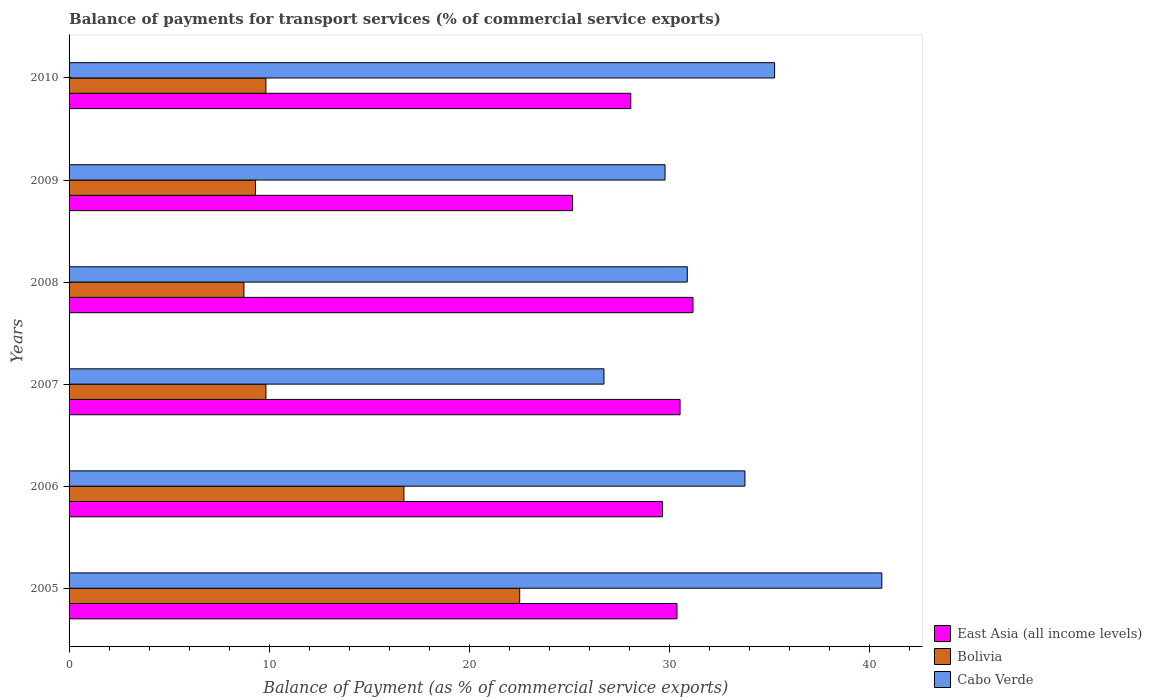How many different coloured bars are there?
Make the answer very short. 3. How many groups of bars are there?
Offer a terse response. 6. Are the number of bars per tick equal to the number of legend labels?
Offer a very short reply. Yes. Are the number of bars on each tick of the Y-axis equal?
Provide a succinct answer. Yes. How many bars are there on the 6th tick from the top?
Ensure brevity in your answer.  3. What is the label of the 6th group of bars from the top?
Your answer should be compact. 2005. What is the balance of payments for transport services in Cabo Verde in 2008?
Provide a succinct answer. 30.91. Across all years, what is the maximum balance of payments for transport services in Cabo Verde?
Your response must be concise. 40.64. Across all years, what is the minimum balance of payments for transport services in East Asia (all income levels)?
Your answer should be very brief. 25.18. In which year was the balance of payments for transport services in Bolivia maximum?
Provide a succinct answer. 2005. What is the total balance of payments for transport services in East Asia (all income levels) in the graph?
Your answer should be compact. 175.08. What is the difference between the balance of payments for transport services in Cabo Verde in 2007 and that in 2008?
Give a very brief answer. -4.17. What is the difference between the balance of payments for transport services in Bolivia in 2006 and the balance of payments for transport services in Cabo Verde in 2009?
Provide a short and direct response. -13.06. What is the average balance of payments for transport services in East Asia (all income levels) per year?
Give a very brief answer. 29.18. In the year 2005, what is the difference between the balance of payments for transport services in Bolivia and balance of payments for transport services in Cabo Verde?
Offer a terse response. -18.11. In how many years, is the balance of payments for transport services in East Asia (all income levels) greater than 14 %?
Offer a very short reply. 6. What is the ratio of the balance of payments for transport services in East Asia (all income levels) in 2007 to that in 2008?
Make the answer very short. 0.98. Is the balance of payments for transport services in Cabo Verde in 2005 less than that in 2009?
Offer a terse response. No. Is the difference between the balance of payments for transport services in Bolivia in 2005 and 2010 greater than the difference between the balance of payments for transport services in Cabo Verde in 2005 and 2010?
Provide a succinct answer. Yes. What is the difference between the highest and the second highest balance of payments for transport services in Cabo Verde?
Offer a very short reply. 5.36. What is the difference between the highest and the lowest balance of payments for transport services in Cabo Verde?
Offer a very short reply. 13.89. In how many years, is the balance of payments for transport services in Cabo Verde greater than the average balance of payments for transport services in Cabo Verde taken over all years?
Your answer should be very brief. 3. What does the 3rd bar from the top in 2010 represents?
Make the answer very short. East Asia (all income levels). What does the 3rd bar from the bottom in 2005 represents?
Keep it short and to the point. Cabo Verde. Is it the case that in every year, the sum of the balance of payments for transport services in Bolivia and balance of payments for transport services in East Asia (all income levels) is greater than the balance of payments for transport services in Cabo Verde?
Give a very brief answer. Yes. How many bars are there?
Provide a succinct answer. 18. Are all the bars in the graph horizontal?
Provide a short and direct response. Yes. What is the difference between two consecutive major ticks on the X-axis?
Your answer should be compact. 10. Are the values on the major ticks of X-axis written in scientific E-notation?
Give a very brief answer. No. Where does the legend appear in the graph?
Your answer should be very brief. Bottom right. What is the title of the graph?
Keep it short and to the point. Balance of payments for transport services (% of commercial service exports). Does "Dominican Republic" appear as one of the legend labels in the graph?
Your response must be concise. No. What is the label or title of the X-axis?
Your response must be concise. Balance of Payment (as % of commercial service exports). What is the Balance of Payment (as % of commercial service exports) of East Asia (all income levels) in 2005?
Your answer should be compact. 30.4. What is the Balance of Payment (as % of commercial service exports) of Bolivia in 2005?
Provide a short and direct response. 22.53. What is the Balance of Payment (as % of commercial service exports) of Cabo Verde in 2005?
Offer a terse response. 40.64. What is the Balance of Payment (as % of commercial service exports) in East Asia (all income levels) in 2006?
Your answer should be very brief. 29.67. What is the Balance of Payment (as % of commercial service exports) in Bolivia in 2006?
Provide a short and direct response. 16.74. What is the Balance of Payment (as % of commercial service exports) in Cabo Verde in 2006?
Your answer should be very brief. 33.79. What is the Balance of Payment (as % of commercial service exports) of East Asia (all income levels) in 2007?
Provide a short and direct response. 30.55. What is the Balance of Payment (as % of commercial service exports) of Bolivia in 2007?
Your answer should be compact. 9.84. What is the Balance of Payment (as % of commercial service exports) of Cabo Verde in 2007?
Make the answer very short. 26.75. What is the Balance of Payment (as % of commercial service exports) of East Asia (all income levels) in 2008?
Your answer should be very brief. 31.2. What is the Balance of Payment (as % of commercial service exports) in Bolivia in 2008?
Your answer should be compact. 8.74. What is the Balance of Payment (as % of commercial service exports) in Cabo Verde in 2008?
Offer a terse response. 30.91. What is the Balance of Payment (as % of commercial service exports) in East Asia (all income levels) in 2009?
Offer a very short reply. 25.18. What is the Balance of Payment (as % of commercial service exports) of Bolivia in 2009?
Provide a succinct answer. 9.32. What is the Balance of Payment (as % of commercial service exports) in Cabo Verde in 2009?
Your answer should be compact. 29.8. What is the Balance of Payment (as % of commercial service exports) in East Asia (all income levels) in 2010?
Give a very brief answer. 28.09. What is the Balance of Payment (as % of commercial service exports) of Bolivia in 2010?
Offer a terse response. 9.84. What is the Balance of Payment (as % of commercial service exports) of Cabo Verde in 2010?
Provide a short and direct response. 35.28. Across all years, what is the maximum Balance of Payment (as % of commercial service exports) in East Asia (all income levels)?
Ensure brevity in your answer.  31.2. Across all years, what is the maximum Balance of Payment (as % of commercial service exports) of Bolivia?
Ensure brevity in your answer.  22.53. Across all years, what is the maximum Balance of Payment (as % of commercial service exports) of Cabo Verde?
Provide a succinct answer. 40.64. Across all years, what is the minimum Balance of Payment (as % of commercial service exports) of East Asia (all income levels)?
Give a very brief answer. 25.18. Across all years, what is the minimum Balance of Payment (as % of commercial service exports) of Bolivia?
Give a very brief answer. 8.74. Across all years, what is the minimum Balance of Payment (as % of commercial service exports) in Cabo Verde?
Your answer should be compact. 26.75. What is the total Balance of Payment (as % of commercial service exports) in East Asia (all income levels) in the graph?
Offer a very short reply. 175.08. What is the total Balance of Payment (as % of commercial service exports) of Bolivia in the graph?
Your response must be concise. 77.03. What is the total Balance of Payment (as % of commercial service exports) in Cabo Verde in the graph?
Give a very brief answer. 197.17. What is the difference between the Balance of Payment (as % of commercial service exports) in East Asia (all income levels) in 2005 and that in 2006?
Give a very brief answer. 0.72. What is the difference between the Balance of Payment (as % of commercial service exports) of Bolivia in 2005 and that in 2006?
Ensure brevity in your answer.  5.79. What is the difference between the Balance of Payment (as % of commercial service exports) in Cabo Verde in 2005 and that in 2006?
Your answer should be compact. 6.85. What is the difference between the Balance of Payment (as % of commercial service exports) in East Asia (all income levels) in 2005 and that in 2007?
Your answer should be compact. -0.15. What is the difference between the Balance of Payment (as % of commercial service exports) in Bolivia in 2005 and that in 2007?
Keep it short and to the point. 12.69. What is the difference between the Balance of Payment (as % of commercial service exports) of Cabo Verde in 2005 and that in 2007?
Your answer should be compact. 13.89. What is the difference between the Balance of Payment (as % of commercial service exports) in East Asia (all income levels) in 2005 and that in 2008?
Offer a very short reply. -0.8. What is the difference between the Balance of Payment (as % of commercial service exports) of Bolivia in 2005 and that in 2008?
Keep it short and to the point. 13.79. What is the difference between the Balance of Payment (as % of commercial service exports) in Cabo Verde in 2005 and that in 2008?
Your answer should be compact. 9.73. What is the difference between the Balance of Payment (as % of commercial service exports) in East Asia (all income levels) in 2005 and that in 2009?
Give a very brief answer. 5.22. What is the difference between the Balance of Payment (as % of commercial service exports) of Bolivia in 2005 and that in 2009?
Offer a very short reply. 13.21. What is the difference between the Balance of Payment (as % of commercial service exports) in Cabo Verde in 2005 and that in 2009?
Keep it short and to the point. 10.84. What is the difference between the Balance of Payment (as % of commercial service exports) of East Asia (all income levels) in 2005 and that in 2010?
Your response must be concise. 2.31. What is the difference between the Balance of Payment (as % of commercial service exports) of Bolivia in 2005 and that in 2010?
Provide a succinct answer. 12.69. What is the difference between the Balance of Payment (as % of commercial service exports) of Cabo Verde in 2005 and that in 2010?
Give a very brief answer. 5.36. What is the difference between the Balance of Payment (as % of commercial service exports) in East Asia (all income levels) in 2006 and that in 2007?
Provide a short and direct response. -0.88. What is the difference between the Balance of Payment (as % of commercial service exports) of Bolivia in 2006 and that in 2007?
Provide a short and direct response. 6.9. What is the difference between the Balance of Payment (as % of commercial service exports) of Cabo Verde in 2006 and that in 2007?
Ensure brevity in your answer.  7.05. What is the difference between the Balance of Payment (as % of commercial service exports) in East Asia (all income levels) in 2006 and that in 2008?
Your answer should be very brief. -1.52. What is the difference between the Balance of Payment (as % of commercial service exports) in Bolivia in 2006 and that in 2008?
Provide a succinct answer. 8. What is the difference between the Balance of Payment (as % of commercial service exports) in Cabo Verde in 2006 and that in 2008?
Your response must be concise. 2.88. What is the difference between the Balance of Payment (as % of commercial service exports) of East Asia (all income levels) in 2006 and that in 2009?
Give a very brief answer. 4.5. What is the difference between the Balance of Payment (as % of commercial service exports) in Bolivia in 2006 and that in 2009?
Ensure brevity in your answer.  7.42. What is the difference between the Balance of Payment (as % of commercial service exports) of Cabo Verde in 2006 and that in 2009?
Make the answer very short. 3.99. What is the difference between the Balance of Payment (as % of commercial service exports) of East Asia (all income levels) in 2006 and that in 2010?
Keep it short and to the point. 1.59. What is the difference between the Balance of Payment (as % of commercial service exports) in Bolivia in 2006 and that in 2010?
Ensure brevity in your answer.  6.9. What is the difference between the Balance of Payment (as % of commercial service exports) in Cabo Verde in 2006 and that in 2010?
Provide a succinct answer. -1.48. What is the difference between the Balance of Payment (as % of commercial service exports) of East Asia (all income levels) in 2007 and that in 2008?
Offer a terse response. -0.65. What is the difference between the Balance of Payment (as % of commercial service exports) in Bolivia in 2007 and that in 2008?
Provide a succinct answer. 1.1. What is the difference between the Balance of Payment (as % of commercial service exports) of Cabo Verde in 2007 and that in 2008?
Your answer should be compact. -4.17. What is the difference between the Balance of Payment (as % of commercial service exports) of East Asia (all income levels) in 2007 and that in 2009?
Offer a very short reply. 5.37. What is the difference between the Balance of Payment (as % of commercial service exports) of Bolivia in 2007 and that in 2009?
Your response must be concise. 0.52. What is the difference between the Balance of Payment (as % of commercial service exports) of Cabo Verde in 2007 and that in 2009?
Provide a succinct answer. -3.05. What is the difference between the Balance of Payment (as % of commercial service exports) of East Asia (all income levels) in 2007 and that in 2010?
Give a very brief answer. 2.46. What is the difference between the Balance of Payment (as % of commercial service exports) in Bolivia in 2007 and that in 2010?
Ensure brevity in your answer.  0. What is the difference between the Balance of Payment (as % of commercial service exports) of Cabo Verde in 2007 and that in 2010?
Make the answer very short. -8.53. What is the difference between the Balance of Payment (as % of commercial service exports) of East Asia (all income levels) in 2008 and that in 2009?
Your answer should be compact. 6.02. What is the difference between the Balance of Payment (as % of commercial service exports) in Bolivia in 2008 and that in 2009?
Make the answer very short. -0.58. What is the difference between the Balance of Payment (as % of commercial service exports) in Cabo Verde in 2008 and that in 2009?
Your answer should be compact. 1.11. What is the difference between the Balance of Payment (as % of commercial service exports) in East Asia (all income levels) in 2008 and that in 2010?
Give a very brief answer. 3.11. What is the difference between the Balance of Payment (as % of commercial service exports) of Bolivia in 2008 and that in 2010?
Provide a short and direct response. -1.1. What is the difference between the Balance of Payment (as % of commercial service exports) in Cabo Verde in 2008 and that in 2010?
Offer a terse response. -4.37. What is the difference between the Balance of Payment (as % of commercial service exports) in East Asia (all income levels) in 2009 and that in 2010?
Your response must be concise. -2.91. What is the difference between the Balance of Payment (as % of commercial service exports) of Bolivia in 2009 and that in 2010?
Provide a succinct answer. -0.52. What is the difference between the Balance of Payment (as % of commercial service exports) of Cabo Verde in 2009 and that in 2010?
Your answer should be very brief. -5.48. What is the difference between the Balance of Payment (as % of commercial service exports) in East Asia (all income levels) in 2005 and the Balance of Payment (as % of commercial service exports) in Bolivia in 2006?
Your answer should be compact. 13.65. What is the difference between the Balance of Payment (as % of commercial service exports) in East Asia (all income levels) in 2005 and the Balance of Payment (as % of commercial service exports) in Cabo Verde in 2006?
Your response must be concise. -3.4. What is the difference between the Balance of Payment (as % of commercial service exports) in Bolivia in 2005 and the Balance of Payment (as % of commercial service exports) in Cabo Verde in 2006?
Offer a terse response. -11.26. What is the difference between the Balance of Payment (as % of commercial service exports) in East Asia (all income levels) in 2005 and the Balance of Payment (as % of commercial service exports) in Bolivia in 2007?
Ensure brevity in your answer.  20.55. What is the difference between the Balance of Payment (as % of commercial service exports) of East Asia (all income levels) in 2005 and the Balance of Payment (as % of commercial service exports) of Cabo Verde in 2007?
Provide a short and direct response. 3.65. What is the difference between the Balance of Payment (as % of commercial service exports) of Bolivia in 2005 and the Balance of Payment (as % of commercial service exports) of Cabo Verde in 2007?
Offer a terse response. -4.21. What is the difference between the Balance of Payment (as % of commercial service exports) of East Asia (all income levels) in 2005 and the Balance of Payment (as % of commercial service exports) of Bolivia in 2008?
Ensure brevity in your answer.  21.65. What is the difference between the Balance of Payment (as % of commercial service exports) of East Asia (all income levels) in 2005 and the Balance of Payment (as % of commercial service exports) of Cabo Verde in 2008?
Offer a terse response. -0.52. What is the difference between the Balance of Payment (as % of commercial service exports) of Bolivia in 2005 and the Balance of Payment (as % of commercial service exports) of Cabo Verde in 2008?
Your response must be concise. -8.38. What is the difference between the Balance of Payment (as % of commercial service exports) of East Asia (all income levels) in 2005 and the Balance of Payment (as % of commercial service exports) of Bolivia in 2009?
Provide a succinct answer. 21.07. What is the difference between the Balance of Payment (as % of commercial service exports) in East Asia (all income levels) in 2005 and the Balance of Payment (as % of commercial service exports) in Cabo Verde in 2009?
Give a very brief answer. 0.6. What is the difference between the Balance of Payment (as % of commercial service exports) in Bolivia in 2005 and the Balance of Payment (as % of commercial service exports) in Cabo Verde in 2009?
Offer a terse response. -7.27. What is the difference between the Balance of Payment (as % of commercial service exports) of East Asia (all income levels) in 2005 and the Balance of Payment (as % of commercial service exports) of Bolivia in 2010?
Offer a very short reply. 20.55. What is the difference between the Balance of Payment (as % of commercial service exports) in East Asia (all income levels) in 2005 and the Balance of Payment (as % of commercial service exports) in Cabo Verde in 2010?
Your answer should be very brief. -4.88. What is the difference between the Balance of Payment (as % of commercial service exports) in Bolivia in 2005 and the Balance of Payment (as % of commercial service exports) in Cabo Verde in 2010?
Offer a very short reply. -12.75. What is the difference between the Balance of Payment (as % of commercial service exports) in East Asia (all income levels) in 2006 and the Balance of Payment (as % of commercial service exports) in Bolivia in 2007?
Keep it short and to the point. 19.83. What is the difference between the Balance of Payment (as % of commercial service exports) in East Asia (all income levels) in 2006 and the Balance of Payment (as % of commercial service exports) in Cabo Verde in 2007?
Make the answer very short. 2.93. What is the difference between the Balance of Payment (as % of commercial service exports) of Bolivia in 2006 and the Balance of Payment (as % of commercial service exports) of Cabo Verde in 2007?
Your response must be concise. -10. What is the difference between the Balance of Payment (as % of commercial service exports) in East Asia (all income levels) in 2006 and the Balance of Payment (as % of commercial service exports) in Bolivia in 2008?
Give a very brief answer. 20.93. What is the difference between the Balance of Payment (as % of commercial service exports) of East Asia (all income levels) in 2006 and the Balance of Payment (as % of commercial service exports) of Cabo Verde in 2008?
Your response must be concise. -1.24. What is the difference between the Balance of Payment (as % of commercial service exports) of Bolivia in 2006 and the Balance of Payment (as % of commercial service exports) of Cabo Verde in 2008?
Give a very brief answer. -14.17. What is the difference between the Balance of Payment (as % of commercial service exports) in East Asia (all income levels) in 2006 and the Balance of Payment (as % of commercial service exports) in Bolivia in 2009?
Make the answer very short. 20.35. What is the difference between the Balance of Payment (as % of commercial service exports) of East Asia (all income levels) in 2006 and the Balance of Payment (as % of commercial service exports) of Cabo Verde in 2009?
Provide a succinct answer. -0.13. What is the difference between the Balance of Payment (as % of commercial service exports) of Bolivia in 2006 and the Balance of Payment (as % of commercial service exports) of Cabo Verde in 2009?
Offer a terse response. -13.06. What is the difference between the Balance of Payment (as % of commercial service exports) of East Asia (all income levels) in 2006 and the Balance of Payment (as % of commercial service exports) of Bolivia in 2010?
Offer a very short reply. 19.83. What is the difference between the Balance of Payment (as % of commercial service exports) of East Asia (all income levels) in 2006 and the Balance of Payment (as % of commercial service exports) of Cabo Verde in 2010?
Keep it short and to the point. -5.61. What is the difference between the Balance of Payment (as % of commercial service exports) of Bolivia in 2006 and the Balance of Payment (as % of commercial service exports) of Cabo Verde in 2010?
Provide a succinct answer. -18.54. What is the difference between the Balance of Payment (as % of commercial service exports) in East Asia (all income levels) in 2007 and the Balance of Payment (as % of commercial service exports) in Bolivia in 2008?
Provide a short and direct response. 21.81. What is the difference between the Balance of Payment (as % of commercial service exports) of East Asia (all income levels) in 2007 and the Balance of Payment (as % of commercial service exports) of Cabo Verde in 2008?
Offer a very short reply. -0.36. What is the difference between the Balance of Payment (as % of commercial service exports) of Bolivia in 2007 and the Balance of Payment (as % of commercial service exports) of Cabo Verde in 2008?
Offer a very short reply. -21.07. What is the difference between the Balance of Payment (as % of commercial service exports) in East Asia (all income levels) in 2007 and the Balance of Payment (as % of commercial service exports) in Bolivia in 2009?
Provide a succinct answer. 21.23. What is the difference between the Balance of Payment (as % of commercial service exports) of East Asia (all income levels) in 2007 and the Balance of Payment (as % of commercial service exports) of Cabo Verde in 2009?
Provide a succinct answer. 0.75. What is the difference between the Balance of Payment (as % of commercial service exports) in Bolivia in 2007 and the Balance of Payment (as % of commercial service exports) in Cabo Verde in 2009?
Offer a very short reply. -19.96. What is the difference between the Balance of Payment (as % of commercial service exports) of East Asia (all income levels) in 2007 and the Balance of Payment (as % of commercial service exports) of Bolivia in 2010?
Give a very brief answer. 20.71. What is the difference between the Balance of Payment (as % of commercial service exports) in East Asia (all income levels) in 2007 and the Balance of Payment (as % of commercial service exports) in Cabo Verde in 2010?
Offer a very short reply. -4.73. What is the difference between the Balance of Payment (as % of commercial service exports) in Bolivia in 2007 and the Balance of Payment (as % of commercial service exports) in Cabo Verde in 2010?
Your answer should be very brief. -25.43. What is the difference between the Balance of Payment (as % of commercial service exports) of East Asia (all income levels) in 2008 and the Balance of Payment (as % of commercial service exports) of Bolivia in 2009?
Make the answer very short. 21.87. What is the difference between the Balance of Payment (as % of commercial service exports) of East Asia (all income levels) in 2008 and the Balance of Payment (as % of commercial service exports) of Cabo Verde in 2009?
Offer a terse response. 1.4. What is the difference between the Balance of Payment (as % of commercial service exports) of Bolivia in 2008 and the Balance of Payment (as % of commercial service exports) of Cabo Verde in 2009?
Provide a succinct answer. -21.06. What is the difference between the Balance of Payment (as % of commercial service exports) of East Asia (all income levels) in 2008 and the Balance of Payment (as % of commercial service exports) of Bolivia in 2010?
Offer a very short reply. 21.35. What is the difference between the Balance of Payment (as % of commercial service exports) of East Asia (all income levels) in 2008 and the Balance of Payment (as % of commercial service exports) of Cabo Verde in 2010?
Your response must be concise. -4.08. What is the difference between the Balance of Payment (as % of commercial service exports) in Bolivia in 2008 and the Balance of Payment (as % of commercial service exports) in Cabo Verde in 2010?
Offer a terse response. -26.53. What is the difference between the Balance of Payment (as % of commercial service exports) of East Asia (all income levels) in 2009 and the Balance of Payment (as % of commercial service exports) of Bolivia in 2010?
Offer a very short reply. 15.33. What is the difference between the Balance of Payment (as % of commercial service exports) of East Asia (all income levels) in 2009 and the Balance of Payment (as % of commercial service exports) of Cabo Verde in 2010?
Offer a very short reply. -10.1. What is the difference between the Balance of Payment (as % of commercial service exports) of Bolivia in 2009 and the Balance of Payment (as % of commercial service exports) of Cabo Verde in 2010?
Make the answer very short. -25.96. What is the average Balance of Payment (as % of commercial service exports) of East Asia (all income levels) per year?
Ensure brevity in your answer.  29.18. What is the average Balance of Payment (as % of commercial service exports) in Bolivia per year?
Provide a succinct answer. 12.84. What is the average Balance of Payment (as % of commercial service exports) of Cabo Verde per year?
Ensure brevity in your answer.  32.86. In the year 2005, what is the difference between the Balance of Payment (as % of commercial service exports) of East Asia (all income levels) and Balance of Payment (as % of commercial service exports) of Bolivia?
Offer a very short reply. 7.86. In the year 2005, what is the difference between the Balance of Payment (as % of commercial service exports) in East Asia (all income levels) and Balance of Payment (as % of commercial service exports) in Cabo Verde?
Your response must be concise. -10.24. In the year 2005, what is the difference between the Balance of Payment (as % of commercial service exports) in Bolivia and Balance of Payment (as % of commercial service exports) in Cabo Verde?
Ensure brevity in your answer.  -18.11. In the year 2006, what is the difference between the Balance of Payment (as % of commercial service exports) of East Asia (all income levels) and Balance of Payment (as % of commercial service exports) of Bolivia?
Offer a very short reply. 12.93. In the year 2006, what is the difference between the Balance of Payment (as % of commercial service exports) of East Asia (all income levels) and Balance of Payment (as % of commercial service exports) of Cabo Verde?
Provide a short and direct response. -4.12. In the year 2006, what is the difference between the Balance of Payment (as % of commercial service exports) in Bolivia and Balance of Payment (as % of commercial service exports) in Cabo Verde?
Make the answer very short. -17.05. In the year 2007, what is the difference between the Balance of Payment (as % of commercial service exports) in East Asia (all income levels) and Balance of Payment (as % of commercial service exports) in Bolivia?
Your response must be concise. 20.71. In the year 2007, what is the difference between the Balance of Payment (as % of commercial service exports) in East Asia (all income levels) and Balance of Payment (as % of commercial service exports) in Cabo Verde?
Your answer should be very brief. 3.8. In the year 2007, what is the difference between the Balance of Payment (as % of commercial service exports) of Bolivia and Balance of Payment (as % of commercial service exports) of Cabo Verde?
Provide a short and direct response. -16.9. In the year 2008, what is the difference between the Balance of Payment (as % of commercial service exports) in East Asia (all income levels) and Balance of Payment (as % of commercial service exports) in Bolivia?
Provide a short and direct response. 22.45. In the year 2008, what is the difference between the Balance of Payment (as % of commercial service exports) of East Asia (all income levels) and Balance of Payment (as % of commercial service exports) of Cabo Verde?
Give a very brief answer. 0.28. In the year 2008, what is the difference between the Balance of Payment (as % of commercial service exports) in Bolivia and Balance of Payment (as % of commercial service exports) in Cabo Verde?
Provide a succinct answer. -22.17. In the year 2009, what is the difference between the Balance of Payment (as % of commercial service exports) of East Asia (all income levels) and Balance of Payment (as % of commercial service exports) of Bolivia?
Offer a very short reply. 15.85. In the year 2009, what is the difference between the Balance of Payment (as % of commercial service exports) of East Asia (all income levels) and Balance of Payment (as % of commercial service exports) of Cabo Verde?
Offer a very short reply. -4.62. In the year 2009, what is the difference between the Balance of Payment (as % of commercial service exports) in Bolivia and Balance of Payment (as % of commercial service exports) in Cabo Verde?
Your answer should be compact. -20.48. In the year 2010, what is the difference between the Balance of Payment (as % of commercial service exports) of East Asia (all income levels) and Balance of Payment (as % of commercial service exports) of Bolivia?
Ensure brevity in your answer.  18.24. In the year 2010, what is the difference between the Balance of Payment (as % of commercial service exports) of East Asia (all income levels) and Balance of Payment (as % of commercial service exports) of Cabo Verde?
Make the answer very short. -7.19. In the year 2010, what is the difference between the Balance of Payment (as % of commercial service exports) in Bolivia and Balance of Payment (as % of commercial service exports) in Cabo Verde?
Keep it short and to the point. -25.44. What is the ratio of the Balance of Payment (as % of commercial service exports) of East Asia (all income levels) in 2005 to that in 2006?
Your response must be concise. 1.02. What is the ratio of the Balance of Payment (as % of commercial service exports) in Bolivia in 2005 to that in 2006?
Your response must be concise. 1.35. What is the ratio of the Balance of Payment (as % of commercial service exports) in Cabo Verde in 2005 to that in 2006?
Your response must be concise. 1.2. What is the ratio of the Balance of Payment (as % of commercial service exports) in Bolivia in 2005 to that in 2007?
Your answer should be very brief. 2.29. What is the ratio of the Balance of Payment (as % of commercial service exports) of Cabo Verde in 2005 to that in 2007?
Ensure brevity in your answer.  1.52. What is the ratio of the Balance of Payment (as % of commercial service exports) in East Asia (all income levels) in 2005 to that in 2008?
Ensure brevity in your answer.  0.97. What is the ratio of the Balance of Payment (as % of commercial service exports) in Bolivia in 2005 to that in 2008?
Ensure brevity in your answer.  2.58. What is the ratio of the Balance of Payment (as % of commercial service exports) of Cabo Verde in 2005 to that in 2008?
Your answer should be very brief. 1.31. What is the ratio of the Balance of Payment (as % of commercial service exports) in East Asia (all income levels) in 2005 to that in 2009?
Provide a short and direct response. 1.21. What is the ratio of the Balance of Payment (as % of commercial service exports) in Bolivia in 2005 to that in 2009?
Your answer should be compact. 2.42. What is the ratio of the Balance of Payment (as % of commercial service exports) in Cabo Verde in 2005 to that in 2009?
Provide a succinct answer. 1.36. What is the ratio of the Balance of Payment (as % of commercial service exports) in East Asia (all income levels) in 2005 to that in 2010?
Provide a succinct answer. 1.08. What is the ratio of the Balance of Payment (as % of commercial service exports) in Bolivia in 2005 to that in 2010?
Give a very brief answer. 2.29. What is the ratio of the Balance of Payment (as % of commercial service exports) in Cabo Verde in 2005 to that in 2010?
Your response must be concise. 1.15. What is the ratio of the Balance of Payment (as % of commercial service exports) in East Asia (all income levels) in 2006 to that in 2007?
Ensure brevity in your answer.  0.97. What is the ratio of the Balance of Payment (as % of commercial service exports) in Bolivia in 2006 to that in 2007?
Keep it short and to the point. 1.7. What is the ratio of the Balance of Payment (as % of commercial service exports) in Cabo Verde in 2006 to that in 2007?
Keep it short and to the point. 1.26. What is the ratio of the Balance of Payment (as % of commercial service exports) of East Asia (all income levels) in 2006 to that in 2008?
Make the answer very short. 0.95. What is the ratio of the Balance of Payment (as % of commercial service exports) in Bolivia in 2006 to that in 2008?
Your answer should be compact. 1.91. What is the ratio of the Balance of Payment (as % of commercial service exports) in Cabo Verde in 2006 to that in 2008?
Provide a short and direct response. 1.09. What is the ratio of the Balance of Payment (as % of commercial service exports) in East Asia (all income levels) in 2006 to that in 2009?
Offer a terse response. 1.18. What is the ratio of the Balance of Payment (as % of commercial service exports) of Bolivia in 2006 to that in 2009?
Give a very brief answer. 1.8. What is the ratio of the Balance of Payment (as % of commercial service exports) of Cabo Verde in 2006 to that in 2009?
Keep it short and to the point. 1.13. What is the ratio of the Balance of Payment (as % of commercial service exports) of East Asia (all income levels) in 2006 to that in 2010?
Ensure brevity in your answer.  1.06. What is the ratio of the Balance of Payment (as % of commercial service exports) of Bolivia in 2006 to that in 2010?
Offer a terse response. 1.7. What is the ratio of the Balance of Payment (as % of commercial service exports) of Cabo Verde in 2006 to that in 2010?
Your answer should be compact. 0.96. What is the ratio of the Balance of Payment (as % of commercial service exports) of East Asia (all income levels) in 2007 to that in 2008?
Make the answer very short. 0.98. What is the ratio of the Balance of Payment (as % of commercial service exports) of Bolivia in 2007 to that in 2008?
Make the answer very short. 1.13. What is the ratio of the Balance of Payment (as % of commercial service exports) in Cabo Verde in 2007 to that in 2008?
Your answer should be compact. 0.87. What is the ratio of the Balance of Payment (as % of commercial service exports) of East Asia (all income levels) in 2007 to that in 2009?
Offer a terse response. 1.21. What is the ratio of the Balance of Payment (as % of commercial service exports) in Bolivia in 2007 to that in 2009?
Your answer should be very brief. 1.06. What is the ratio of the Balance of Payment (as % of commercial service exports) in Cabo Verde in 2007 to that in 2009?
Give a very brief answer. 0.9. What is the ratio of the Balance of Payment (as % of commercial service exports) of East Asia (all income levels) in 2007 to that in 2010?
Offer a very short reply. 1.09. What is the ratio of the Balance of Payment (as % of commercial service exports) in Cabo Verde in 2007 to that in 2010?
Keep it short and to the point. 0.76. What is the ratio of the Balance of Payment (as % of commercial service exports) in East Asia (all income levels) in 2008 to that in 2009?
Offer a terse response. 1.24. What is the ratio of the Balance of Payment (as % of commercial service exports) of Bolivia in 2008 to that in 2009?
Provide a succinct answer. 0.94. What is the ratio of the Balance of Payment (as % of commercial service exports) in Cabo Verde in 2008 to that in 2009?
Your answer should be very brief. 1.04. What is the ratio of the Balance of Payment (as % of commercial service exports) of East Asia (all income levels) in 2008 to that in 2010?
Make the answer very short. 1.11. What is the ratio of the Balance of Payment (as % of commercial service exports) of Bolivia in 2008 to that in 2010?
Keep it short and to the point. 0.89. What is the ratio of the Balance of Payment (as % of commercial service exports) in Cabo Verde in 2008 to that in 2010?
Your answer should be very brief. 0.88. What is the ratio of the Balance of Payment (as % of commercial service exports) of East Asia (all income levels) in 2009 to that in 2010?
Provide a short and direct response. 0.9. What is the ratio of the Balance of Payment (as % of commercial service exports) in Bolivia in 2009 to that in 2010?
Your response must be concise. 0.95. What is the ratio of the Balance of Payment (as % of commercial service exports) in Cabo Verde in 2009 to that in 2010?
Keep it short and to the point. 0.84. What is the difference between the highest and the second highest Balance of Payment (as % of commercial service exports) of East Asia (all income levels)?
Your answer should be very brief. 0.65. What is the difference between the highest and the second highest Balance of Payment (as % of commercial service exports) of Bolivia?
Keep it short and to the point. 5.79. What is the difference between the highest and the second highest Balance of Payment (as % of commercial service exports) of Cabo Verde?
Keep it short and to the point. 5.36. What is the difference between the highest and the lowest Balance of Payment (as % of commercial service exports) in East Asia (all income levels)?
Your answer should be compact. 6.02. What is the difference between the highest and the lowest Balance of Payment (as % of commercial service exports) of Bolivia?
Provide a short and direct response. 13.79. What is the difference between the highest and the lowest Balance of Payment (as % of commercial service exports) of Cabo Verde?
Ensure brevity in your answer.  13.89. 